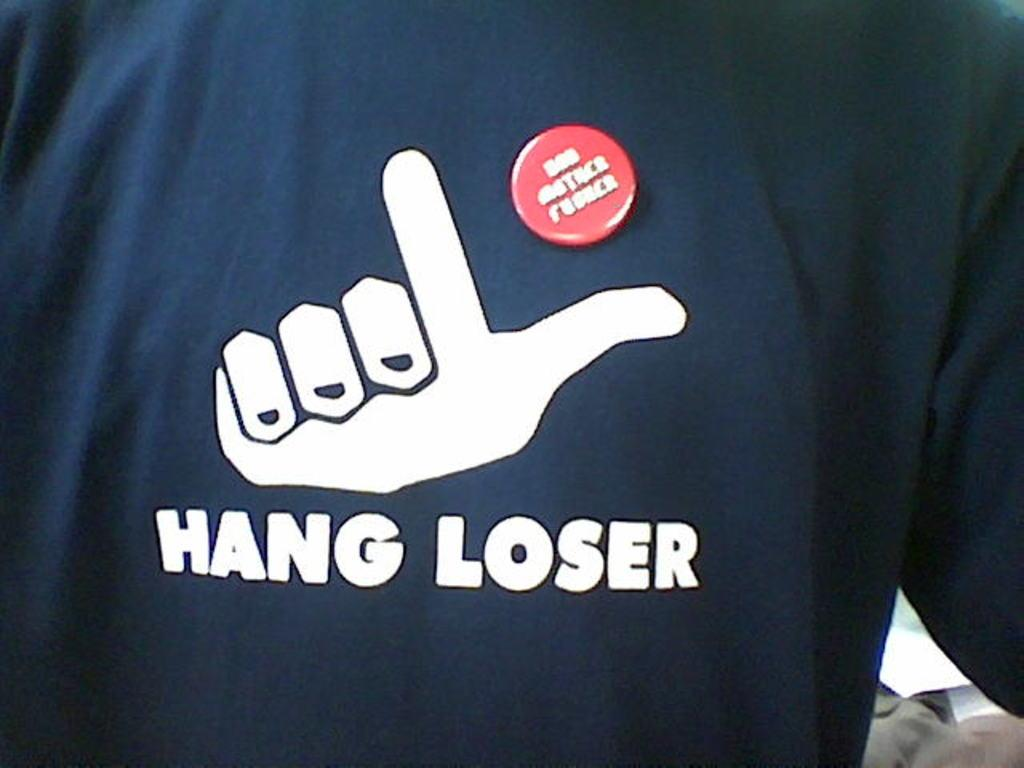<image>
Summarize the visual content of the image. A shirt with a logo and the words Hang Loser on it. 